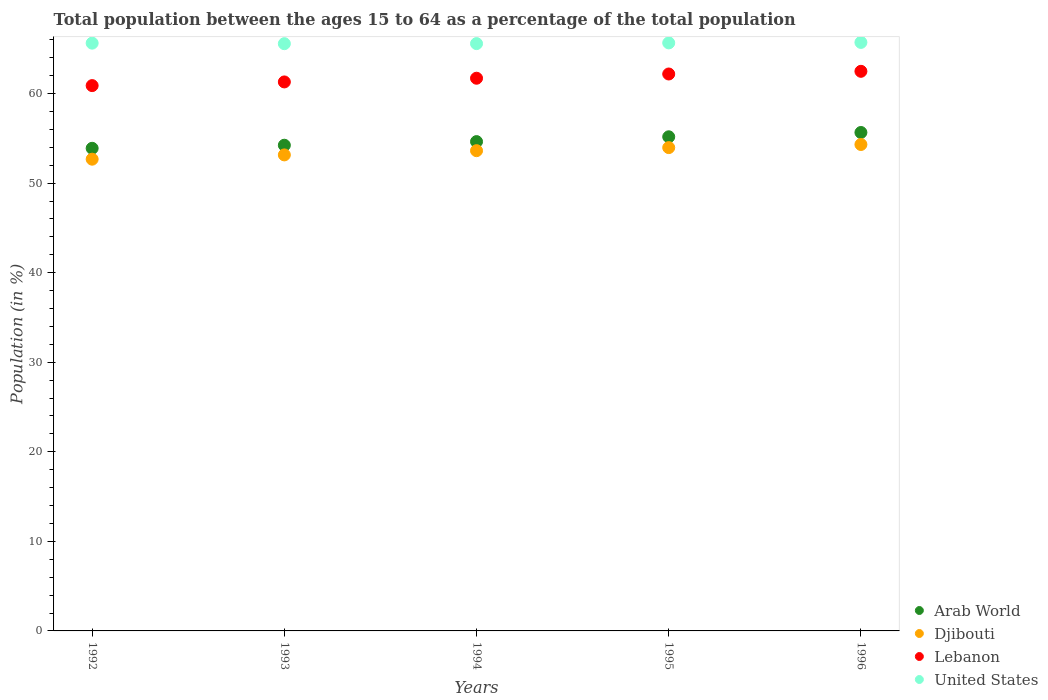How many different coloured dotlines are there?
Your response must be concise. 4. What is the percentage of the population ages 15 to 64 in United States in 1995?
Give a very brief answer. 65.66. Across all years, what is the maximum percentage of the population ages 15 to 64 in Djibouti?
Give a very brief answer. 54.31. Across all years, what is the minimum percentage of the population ages 15 to 64 in Lebanon?
Keep it short and to the point. 60.89. In which year was the percentage of the population ages 15 to 64 in Lebanon maximum?
Provide a succinct answer. 1996. In which year was the percentage of the population ages 15 to 64 in United States minimum?
Give a very brief answer. 1993. What is the total percentage of the population ages 15 to 64 in Arab World in the graph?
Provide a short and direct response. 273.59. What is the difference between the percentage of the population ages 15 to 64 in Arab World in 1994 and that in 1996?
Your response must be concise. -1.02. What is the difference between the percentage of the population ages 15 to 64 in Lebanon in 1992 and the percentage of the population ages 15 to 64 in United States in 1996?
Your answer should be compact. -4.82. What is the average percentage of the population ages 15 to 64 in United States per year?
Your answer should be compact. 65.63. In the year 1996, what is the difference between the percentage of the population ages 15 to 64 in Arab World and percentage of the population ages 15 to 64 in United States?
Your response must be concise. -10.06. What is the ratio of the percentage of the population ages 15 to 64 in Djibouti in 1992 to that in 1993?
Your answer should be very brief. 0.99. Is the percentage of the population ages 15 to 64 in Djibouti in 1994 less than that in 1996?
Provide a succinct answer. Yes. What is the difference between the highest and the second highest percentage of the population ages 15 to 64 in Arab World?
Ensure brevity in your answer.  0.48. What is the difference between the highest and the lowest percentage of the population ages 15 to 64 in Arab World?
Provide a short and direct response. 1.77. Is the sum of the percentage of the population ages 15 to 64 in Arab World in 1993 and 1995 greater than the maximum percentage of the population ages 15 to 64 in United States across all years?
Offer a terse response. Yes. Is it the case that in every year, the sum of the percentage of the population ages 15 to 64 in United States and percentage of the population ages 15 to 64 in Lebanon  is greater than the percentage of the population ages 15 to 64 in Djibouti?
Provide a short and direct response. Yes. Is the percentage of the population ages 15 to 64 in United States strictly less than the percentage of the population ages 15 to 64 in Arab World over the years?
Offer a terse response. No. How many dotlines are there?
Offer a terse response. 4. What is the difference between two consecutive major ticks on the Y-axis?
Your answer should be very brief. 10. Does the graph contain grids?
Keep it short and to the point. No. Where does the legend appear in the graph?
Give a very brief answer. Bottom right. How many legend labels are there?
Your answer should be compact. 4. How are the legend labels stacked?
Your answer should be compact. Vertical. What is the title of the graph?
Make the answer very short. Total population between the ages 15 to 64 as a percentage of the total population. Does "Dominica" appear as one of the legend labels in the graph?
Your answer should be very brief. No. What is the Population (in %) in Arab World in 1992?
Offer a terse response. 53.89. What is the Population (in %) of Djibouti in 1992?
Offer a very short reply. 52.67. What is the Population (in %) of Lebanon in 1992?
Your answer should be very brief. 60.89. What is the Population (in %) in United States in 1992?
Give a very brief answer. 65.63. What is the Population (in %) of Arab World in 1993?
Ensure brevity in your answer.  54.23. What is the Population (in %) in Djibouti in 1993?
Offer a very short reply. 53.15. What is the Population (in %) of Lebanon in 1993?
Your answer should be very brief. 61.3. What is the Population (in %) of United States in 1993?
Keep it short and to the point. 65.57. What is the Population (in %) in Arab World in 1994?
Give a very brief answer. 54.64. What is the Population (in %) of Djibouti in 1994?
Make the answer very short. 53.62. What is the Population (in %) in Lebanon in 1994?
Your answer should be compact. 61.71. What is the Population (in %) of United States in 1994?
Provide a short and direct response. 65.58. What is the Population (in %) in Arab World in 1995?
Offer a very short reply. 55.17. What is the Population (in %) of Djibouti in 1995?
Provide a succinct answer. 53.97. What is the Population (in %) in Lebanon in 1995?
Ensure brevity in your answer.  62.19. What is the Population (in %) in United States in 1995?
Your answer should be very brief. 65.66. What is the Population (in %) in Arab World in 1996?
Provide a short and direct response. 55.65. What is the Population (in %) in Djibouti in 1996?
Offer a very short reply. 54.31. What is the Population (in %) of Lebanon in 1996?
Your response must be concise. 62.49. What is the Population (in %) of United States in 1996?
Your answer should be compact. 65.71. Across all years, what is the maximum Population (in %) of Arab World?
Provide a short and direct response. 55.65. Across all years, what is the maximum Population (in %) of Djibouti?
Make the answer very short. 54.31. Across all years, what is the maximum Population (in %) in Lebanon?
Ensure brevity in your answer.  62.49. Across all years, what is the maximum Population (in %) in United States?
Provide a succinct answer. 65.71. Across all years, what is the minimum Population (in %) in Arab World?
Your answer should be very brief. 53.89. Across all years, what is the minimum Population (in %) of Djibouti?
Your answer should be compact. 52.67. Across all years, what is the minimum Population (in %) in Lebanon?
Your response must be concise. 60.89. Across all years, what is the minimum Population (in %) in United States?
Provide a short and direct response. 65.57. What is the total Population (in %) in Arab World in the graph?
Provide a short and direct response. 273.59. What is the total Population (in %) in Djibouti in the graph?
Your answer should be compact. 267.73. What is the total Population (in %) of Lebanon in the graph?
Ensure brevity in your answer.  308.57. What is the total Population (in %) in United States in the graph?
Provide a short and direct response. 328.15. What is the difference between the Population (in %) in Arab World in 1992 and that in 1993?
Offer a terse response. -0.34. What is the difference between the Population (in %) of Djibouti in 1992 and that in 1993?
Provide a short and direct response. -0.48. What is the difference between the Population (in %) of Lebanon in 1992 and that in 1993?
Ensure brevity in your answer.  -0.41. What is the difference between the Population (in %) in United States in 1992 and that in 1993?
Your response must be concise. 0.06. What is the difference between the Population (in %) of Arab World in 1992 and that in 1994?
Provide a succinct answer. -0.75. What is the difference between the Population (in %) in Djibouti in 1992 and that in 1994?
Your answer should be compact. -0.95. What is the difference between the Population (in %) of Lebanon in 1992 and that in 1994?
Offer a terse response. -0.82. What is the difference between the Population (in %) of United States in 1992 and that in 1994?
Offer a very short reply. 0.05. What is the difference between the Population (in %) in Arab World in 1992 and that in 1995?
Make the answer very short. -1.28. What is the difference between the Population (in %) of Djibouti in 1992 and that in 1995?
Your answer should be compact. -1.29. What is the difference between the Population (in %) of Lebanon in 1992 and that in 1995?
Provide a succinct answer. -1.3. What is the difference between the Population (in %) in United States in 1992 and that in 1995?
Give a very brief answer. -0.03. What is the difference between the Population (in %) in Arab World in 1992 and that in 1996?
Provide a succinct answer. -1.77. What is the difference between the Population (in %) in Djibouti in 1992 and that in 1996?
Ensure brevity in your answer.  -1.64. What is the difference between the Population (in %) of Lebanon in 1992 and that in 1996?
Your answer should be compact. -1.6. What is the difference between the Population (in %) of United States in 1992 and that in 1996?
Offer a terse response. -0.08. What is the difference between the Population (in %) of Arab World in 1993 and that in 1994?
Give a very brief answer. -0.4. What is the difference between the Population (in %) in Djibouti in 1993 and that in 1994?
Your answer should be compact. -0.47. What is the difference between the Population (in %) of Lebanon in 1993 and that in 1994?
Your response must be concise. -0.41. What is the difference between the Population (in %) in United States in 1993 and that in 1994?
Offer a very short reply. -0.01. What is the difference between the Population (in %) in Arab World in 1993 and that in 1995?
Provide a succinct answer. -0.94. What is the difference between the Population (in %) of Djibouti in 1993 and that in 1995?
Your answer should be compact. -0.81. What is the difference between the Population (in %) of Lebanon in 1993 and that in 1995?
Ensure brevity in your answer.  -0.89. What is the difference between the Population (in %) in United States in 1993 and that in 1995?
Provide a short and direct response. -0.09. What is the difference between the Population (in %) in Arab World in 1993 and that in 1996?
Offer a very short reply. -1.42. What is the difference between the Population (in %) in Djibouti in 1993 and that in 1996?
Give a very brief answer. -1.16. What is the difference between the Population (in %) in Lebanon in 1993 and that in 1996?
Provide a succinct answer. -1.19. What is the difference between the Population (in %) of United States in 1993 and that in 1996?
Ensure brevity in your answer.  -0.14. What is the difference between the Population (in %) of Arab World in 1994 and that in 1995?
Ensure brevity in your answer.  -0.54. What is the difference between the Population (in %) of Djibouti in 1994 and that in 1995?
Make the answer very short. -0.34. What is the difference between the Population (in %) of Lebanon in 1994 and that in 1995?
Your response must be concise. -0.47. What is the difference between the Population (in %) in United States in 1994 and that in 1995?
Offer a terse response. -0.08. What is the difference between the Population (in %) in Arab World in 1994 and that in 1996?
Your answer should be very brief. -1.02. What is the difference between the Population (in %) of Djibouti in 1994 and that in 1996?
Keep it short and to the point. -0.69. What is the difference between the Population (in %) in Lebanon in 1994 and that in 1996?
Provide a short and direct response. -0.77. What is the difference between the Population (in %) of United States in 1994 and that in 1996?
Make the answer very short. -0.13. What is the difference between the Population (in %) of Arab World in 1995 and that in 1996?
Provide a short and direct response. -0.48. What is the difference between the Population (in %) in Djibouti in 1995 and that in 1996?
Give a very brief answer. -0.35. What is the difference between the Population (in %) in Lebanon in 1995 and that in 1996?
Provide a succinct answer. -0.3. What is the difference between the Population (in %) of United States in 1995 and that in 1996?
Provide a succinct answer. -0.05. What is the difference between the Population (in %) of Arab World in 1992 and the Population (in %) of Djibouti in 1993?
Your answer should be very brief. 0.74. What is the difference between the Population (in %) in Arab World in 1992 and the Population (in %) in Lebanon in 1993?
Provide a short and direct response. -7.41. What is the difference between the Population (in %) in Arab World in 1992 and the Population (in %) in United States in 1993?
Make the answer very short. -11.68. What is the difference between the Population (in %) in Djibouti in 1992 and the Population (in %) in Lebanon in 1993?
Your response must be concise. -8.63. What is the difference between the Population (in %) of Djibouti in 1992 and the Population (in %) of United States in 1993?
Give a very brief answer. -12.9. What is the difference between the Population (in %) of Lebanon in 1992 and the Population (in %) of United States in 1993?
Offer a very short reply. -4.68. What is the difference between the Population (in %) in Arab World in 1992 and the Population (in %) in Djibouti in 1994?
Your answer should be compact. 0.27. What is the difference between the Population (in %) of Arab World in 1992 and the Population (in %) of Lebanon in 1994?
Provide a short and direct response. -7.82. What is the difference between the Population (in %) of Arab World in 1992 and the Population (in %) of United States in 1994?
Ensure brevity in your answer.  -11.69. What is the difference between the Population (in %) in Djibouti in 1992 and the Population (in %) in Lebanon in 1994?
Provide a succinct answer. -9.04. What is the difference between the Population (in %) in Djibouti in 1992 and the Population (in %) in United States in 1994?
Provide a succinct answer. -12.91. What is the difference between the Population (in %) of Lebanon in 1992 and the Population (in %) of United States in 1994?
Provide a succinct answer. -4.69. What is the difference between the Population (in %) of Arab World in 1992 and the Population (in %) of Djibouti in 1995?
Your answer should be very brief. -0.08. What is the difference between the Population (in %) in Arab World in 1992 and the Population (in %) in Lebanon in 1995?
Keep it short and to the point. -8.3. What is the difference between the Population (in %) of Arab World in 1992 and the Population (in %) of United States in 1995?
Offer a terse response. -11.77. What is the difference between the Population (in %) of Djibouti in 1992 and the Population (in %) of Lebanon in 1995?
Make the answer very short. -9.51. What is the difference between the Population (in %) in Djibouti in 1992 and the Population (in %) in United States in 1995?
Provide a succinct answer. -12.99. What is the difference between the Population (in %) in Lebanon in 1992 and the Population (in %) in United States in 1995?
Provide a succinct answer. -4.77. What is the difference between the Population (in %) in Arab World in 1992 and the Population (in %) in Djibouti in 1996?
Offer a very short reply. -0.42. What is the difference between the Population (in %) in Arab World in 1992 and the Population (in %) in Lebanon in 1996?
Make the answer very short. -8.6. What is the difference between the Population (in %) of Arab World in 1992 and the Population (in %) of United States in 1996?
Offer a terse response. -11.82. What is the difference between the Population (in %) in Djibouti in 1992 and the Population (in %) in Lebanon in 1996?
Ensure brevity in your answer.  -9.81. What is the difference between the Population (in %) of Djibouti in 1992 and the Population (in %) of United States in 1996?
Your response must be concise. -13.04. What is the difference between the Population (in %) of Lebanon in 1992 and the Population (in %) of United States in 1996?
Offer a terse response. -4.82. What is the difference between the Population (in %) in Arab World in 1993 and the Population (in %) in Djibouti in 1994?
Give a very brief answer. 0.61. What is the difference between the Population (in %) in Arab World in 1993 and the Population (in %) in Lebanon in 1994?
Offer a very short reply. -7.48. What is the difference between the Population (in %) in Arab World in 1993 and the Population (in %) in United States in 1994?
Your answer should be compact. -11.35. What is the difference between the Population (in %) in Djibouti in 1993 and the Population (in %) in Lebanon in 1994?
Provide a short and direct response. -8.56. What is the difference between the Population (in %) of Djibouti in 1993 and the Population (in %) of United States in 1994?
Offer a terse response. -12.43. What is the difference between the Population (in %) of Lebanon in 1993 and the Population (in %) of United States in 1994?
Provide a short and direct response. -4.28. What is the difference between the Population (in %) of Arab World in 1993 and the Population (in %) of Djibouti in 1995?
Your answer should be compact. 0.27. What is the difference between the Population (in %) in Arab World in 1993 and the Population (in %) in Lebanon in 1995?
Make the answer very short. -7.95. What is the difference between the Population (in %) of Arab World in 1993 and the Population (in %) of United States in 1995?
Provide a short and direct response. -11.43. What is the difference between the Population (in %) in Djibouti in 1993 and the Population (in %) in Lebanon in 1995?
Offer a terse response. -9.03. What is the difference between the Population (in %) of Djibouti in 1993 and the Population (in %) of United States in 1995?
Your answer should be very brief. -12.51. What is the difference between the Population (in %) of Lebanon in 1993 and the Population (in %) of United States in 1995?
Offer a terse response. -4.36. What is the difference between the Population (in %) of Arab World in 1993 and the Population (in %) of Djibouti in 1996?
Make the answer very short. -0.08. What is the difference between the Population (in %) in Arab World in 1993 and the Population (in %) in Lebanon in 1996?
Make the answer very short. -8.25. What is the difference between the Population (in %) of Arab World in 1993 and the Population (in %) of United States in 1996?
Make the answer very short. -11.48. What is the difference between the Population (in %) of Djibouti in 1993 and the Population (in %) of Lebanon in 1996?
Provide a short and direct response. -9.33. What is the difference between the Population (in %) of Djibouti in 1993 and the Population (in %) of United States in 1996?
Your answer should be very brief. -12.56. What is the difference between the Population (in %) in Lebanon in 1993 and the Population (in %) in United States in 1996?
Make the answer very short. -4.41. What is the difference between the Population (in %) in Arab World in 1994 and the Population (in %) in Djibouti in 1995?
Your response must be concise. 0.67. What is the difference between the Population (in %) in Arab World in 1994 and the Population (in %) in Lebanon in 1995?
Your response must be concise. -7.55. What is the difference between the Population (in %) of Arab World in 1994 and the Population (in %) of United States in 1995?
Your answer should be compact. -11.02. What is the difference between the Population (in %) of Djibouti in 1994 and the Population (in %) of Lebanon in 1995?
Offer a very short reply. -8.56. What is the difference between the Population (in %) in Djibouti in 1994 and the Population (in %) in United States in 1995?
Ensure brevity in your answer.  -12.04. What is the difference between the Population (in %) of Lebanon in 1994 and the Population (in %) of United States in 1995?
Give a very brief answer. -3.95. What is the difference between the Population (in %) in Arab World in 1994 and the Population (in %) in Djibouti in 1996?
Ensure brevity in your answer.  0.32. What is the difference between the Population (in %) of Arab World in 1994 and the Population (in %) of Lebanon in 1996?
Make the answer very short. -7.85. What is the difference between the Population (in %) in Arab World in 1994 and the Population (in %) in United States in 1996?
Ensure brevity in your answer.  -11.08. What is the difference between the Population (in %) of Djibouti in 1994 and the Population (in %) of Lebanon in 1996?
Ensure brevity in your answer.  -8.86. What is the difference between the Population (in %) of Djibouti in 1994 and the Population (in %) of United States in 1996?
Your answer should be very brief. -12.09. What is the difference between the Population (in %) in Lebanon in 1994 and the Population (in %) in United States in 1996?
Ensure brevity in your answer.  -4. What is the difference between the Population (in %) of Arab World in 1995 and the Population (in %) of Djibouti in 1996?
Provide a short and direct response. 0.86. What is the difference between the Population (in %) of Arab World in 1995 and the Population (in %) of Lebanon in 1996?
Offer a terse response. -7.31. What is the difference between the Population (in %) in Arab World in 1995 and the Population (in %) in United States in 1996?
Give a very brief answer. -10.54. What is the difference between the Population (in %) in Djibouti in 1995 and the Population (in %) in Lebanon in 1996?
Your response must be concise. -8.52. What is the difference between the Population (in %) of Djibouti in 1995 and the Population (in %) of United States in 1996?
Provide a succinct answer. -11.75. What is the difference between the Population (in %) of Lebanon in 1995 and the Population (in %) of United States in 1996?
Provide a short and direct response. -3.53. What is the average Population (in %) of Arab World per year?
Give a very brief answer. 54.72. What is the average Population (in %) in Djibouti per year?
Provide a short and direct response. 53.55. What is the average Population (in %) of Lebanon per year?
Your answer should be very brief. 61.71. What is the average Population (in %) of United States per year?
Ensure brevity in your answer.  65.63. In the year 1992, what is the difference between the Population (in %) in Arab World and Population (in %) in Djibouti?
Offer a terse response. 1.22. In the year 1992, what is the difference between the Population (in %) of Arab World and Population (in %) of Lebanon?
Ensure brevity in your answer.  -7. In the year 1992, what is the difference between the Population (in %) in Arab World and Population (in %) in United States?
Your answer should be very brief. -11.74. In the year 1992, what is the difference between the Population (in %) in Djibouti and Population (in %) in Lebanon?
Offer a very short reply. -8.22. In the year 1992, what is the difference between the Population (in %) in Djibouti and Population (in %) in United States?
Your answer should be very brief. -12.96. In the year 1992, what is the difference between the Population (in %) of Lebanon and Population (in %) of United States?
Offer a terse response. -4.74. In the year 1993, what is the difference between the Population (in %) in Arab World and Population (in %) in Djibouti?
Ensure brevity in your answer.  1.08. In the year 1993, what is the difference between the Population (in %) in Arab World and Population (in %) in Lebanon?
Provide a short and direct response. -7.07. In the year 1993, what is the difference between the Population (in %) of Arab World and Population (in %) of United States?
Ensure brevity in your answer.  -11.34. In the year 1993, what is the difference between the Population (in %) in Djibouti and Population (in %) in Lebanon?
Provide a succinct answer. -8.15. In the year 1993, what is the difference between the Population (in %) in Djibouti and Population (in %) in United States?
Your answer should be compact. -12.42. In the year 1993, what is the difference between the Population (in %) of Lebanon and Population (in %) of United States?
Your answer should be very brief. -4.27. In the year 1994, what is the difference between the Population (in %) in Arab World and Population (in %) in Djibouti?
Your answer should be compact. 1.01. In the year 1994, what is the difference between the Population (in %) of Arab World and Population (in %) of Lebanon?
Offer a very short reply. -7.08. In the year 1994, what is the difference between the Population (in %) in Arab World and Population (in %) in United States?
Offer a terse response. -10.94. In the year 1994, what is the difference between the Population (in %) of Djibouti and Population (in %) of Lebanon?
Offer a very short reply. -8.09. In the year 1994, what is the difference between the Population (in %) in Djibouti and Population (in %) in United States?
Give a very brief answer. -11.96. In the year 1994, what is the difference between the Population (in %) of Lebanon and Population (in %) of United States?
Offer a terse response. -3.87. In the year 1995, what is the difference between the Population (in %) in Arab World and Population (in %) in Djibouti?
Provide a succinct answer. 1.21. In the year 1995, what is the difference between the Population (in %) of Arab World and Population (in %) of Lebanon?
Provide a short and direct response. -7.01. In the year 1995, what is the difference between the Population (in %) in Arab World and Population (in %) in United States?
Make the answer very short. -10.49. In the year 1995, what is the difference between the Population (in %) in Djibouti and Population (in %) in Lebanon?
Ensure brevity in your answer.  -8.22. In the year 1995, what is the difference between the Population (in %) of Djibouti and Population (in %) of United States?
Offer a very short reply. -11.69. In the year 1995, what is the difference between the Population (in %) of Lebanon and Population (in %) of United States?
Ensure brevity in your answer.  -3.47. In the year 1996, what is the difference between the Population (in %) in Arab World and Population (in %) in Djibouti?
Your response must be concise. 1.34. In the year 1996, what is the difference between the Population (in %) of Arab World and Population (in %) of Lebanon?
Make the answer very short. -6.83. In the year 1996, what is the difference between the Population (in %) of Arab World and Population (in %) of United States?
Ensure brevity in your answer.  -10.06. In the year 1996, what is the difference between the Population (in %) of Djibouti and Population (in %) of Lebanon?
Offer a terse response. -8.17. In the year 1996, what is the difference between the Population (in %) of Djibouti and Population (in %) of United States?
Provide a short and direct response. -11.4. In the year 1996, what is the difference between the Population (in %) of Lebanon and Population (in %) of United States?
Keep it short and to the point. -3.23. What is the ratio of the Population (in %) of Lebanon in 1992 to that in 1993?
Your answer should be compact. 0.99. What is the ratio of the Population (in %) in United States in 1992 to that in 1993?
Your answer should be very brief. 1. What is the ratio of the Population (in %) of Arab World in 1992 to that in 1994?
Your response must be concise. 0.99. What is the ratio of the Population (in %) of Djibouti in 1992 to that in 1994?
Keep it short and to the point. 0.98. What is the ratio of the Population (in %) in Lebanon in 1992 to that in 1994?
Give a very brief answer. 0.99. What is the ratio of the Population (in %) in United States in 1992 to that in 1994?
Ensure brevity in your answer.  1. What is the ratio of the Population (in %) of Arab World in 1992 to that in 1995?
Offer a terse response. 0.98. What is the ratio of the Population (in %) in Lebanon in 1992 to that in 1995?
Ensure brevity in your answer.  0.98. What is the ratio of the Population (in %) in United States in 1992 to that in 1995?
Give a very brief answer. 1. What is the ratio of the Population (in %) in Arab World in 1992 to that in 1996?
Provide a succinct answer. 0.97. What is the ratio of the Population (in %) in Djibouti in 1992 to that in 1996?
Give a very brief answer. 0.97. What is the ratio of the Population (in %) of Lebanon in 1992 to that in 1996?
Give a very brief answer. 0.97. What is the ratio of the Population (in %) of Arab World in 1993 to that in 1994?
Provide a succinct answer. 0.99. What is the ratio of the Population (in %) in Lebanon in 1993 to that in 1994?
Provide a short and direct response. 0.99. What is the ratio of the Population (in %) in United States in 1993 to that in 1994?
Your answer should be compact. 1. What is the ratio of the Population (in %) of Arab World in 1993 to that in 1995?
Keep it short and to the point. 0.98. What is the ratio of the Population (in %) in Djibouti in 1993 to that in 1995?
Make the answer very short. 0.98. What is the ratio of the Population (in %) in Lebanon in 1993 to that in 1995?
Your answer should be very brief. 0.99. What is the ratio of the Population (in %) in Arab World in 1993 to that in 1996?
Keep it short and to the point. 0.97. What is the ratio of the Population (in %) of Djibouti in 1993 to that in 1996?
Provide a short and direct response. 0.98. What is the ratio of the Population (in %) in United States in 1993 to that in 1996?
Offer a very short reply. 1. What is the ratio of the Population (in %) in Arab World in 1994 to that in 1995?
Offer a very short reply. 0.99. What is the ratio of the Population (in %) in Djibouti in 1994 to that in 1995?
Ensure brevity in your answer.  0.99. What is the ratio of the Population (in %) of Arab World in 1994 to that in 1996?
Give a very brief answer. 0.98. What is the ratio of the Population (in %) of Djibouti in 1994 to that in 1996?
Make the answer very short. 0.99. What is the ratio of the Population (in %) of Lebanon in 1994 to that in 1996?
Give a very brief answer. 0.99. What is the ratio of the Population (in %) of Lebanon in 1995 to that in 1996?
Offer a very short reply. 1. What is the difference between the highest and the second highest Population (in %) in Arab World?
Make the answer very short. 0.48. What is the difference between the highest and the second highest Population (in %) in Djibouti?
Your response must be concise. 0.35. What is the difference between the highest and the second highest Population (in %) of Lebanon?
Give a very brief answer. 0.3. What is the difference between the highest and the second highest Population (in %) of United States?
Offer a terse response. 0.05. What is the difference between the highest and the lowest Population (in %) of Arab World?
Provide a succinct answer. 1.77. What is the difference between the highest and the lowest Population (in %) of Djibouti?
Your response must be concise. 1.64. What is the difference between the highest and the lowest Population (in %) in Lebanon?
Provide a succinct answer. 1.6. What is the difference between the highest and the lowest Population (in %) of United States?
Ensure brevity in your answer.  0.14. 